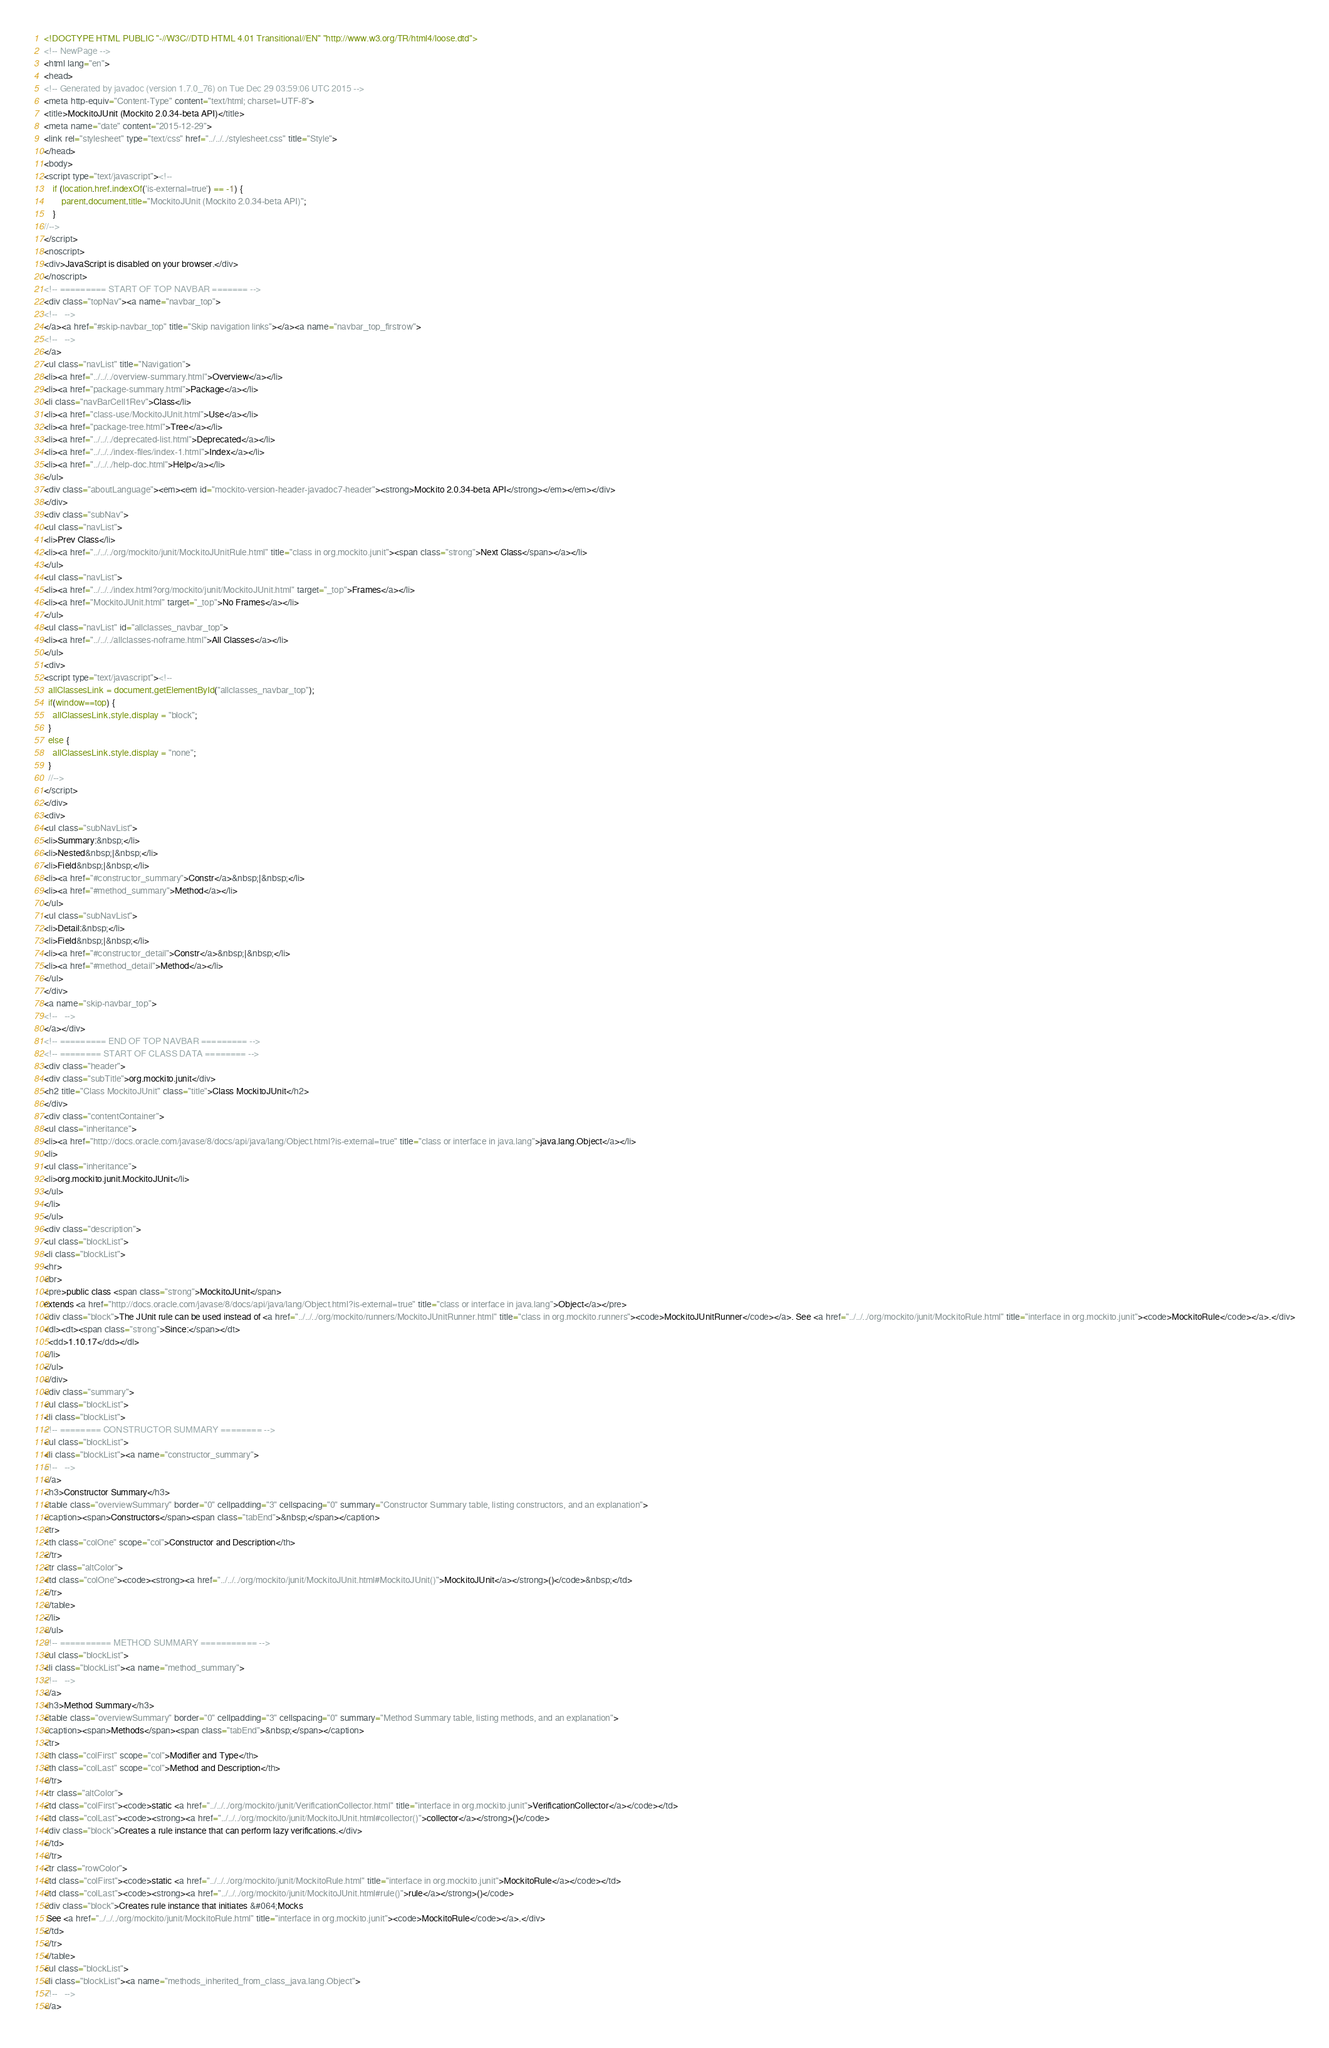<code> <loc_0><loc_0><loc_500><loc_500><_HTML_><!DOCTYPE HTML PUBLIC "-//W3C//DTD HTML 4.01 Transitional//EN" "http://www.w3.org/TR/html4/loose.dtd">
<!-- NewPage -->
<html lang="en">
<head>
<!-- Generated by javadoc (version 1.7.0_76) on Tue Dec 29 03:59:06 UTC 2015 -->
<meta http-equiv="Content-Type" content="text/html; charset=UTF-8">
<title>MockitoJUnit (Mockito 2.0.34-beta API)</title>
<meta name="date" content="2015-12-29">
<link rel="stylesheet" type="text/css" href="../../../stylesheet.css" title="Style">
</head>
<body>
<script type="text/javascript"><!--
    if (location.href.indexOf('is-external=true') == -1) {
        parent.document.title="MockitoJUnit (Mockito 2.0.34-beta API)";
    }
//-->
</script>
<noscript>
<div>JavaScript is disabled on your browser.</div>
</noscript>
<!-- ========= START OF TOP NAVBAR ======= -->
<div class="topNav"><a name="navbar_top">
<!--   -->
</a><a href="#skip-navbar_top" title="Skip navigation links"></a><a name="navbar_top_firstrow">
<!--   -->
</a>
<ul class="navList" title="Navigation">
<li><a href="../../../overview-summary.html">Overview</a></li>
<li><a href="package-summary.html">Package</a></li>
<li class="navBarCell1Rev">Class</li>
<li><a href="class-use/MockitoJUnit.html">Use</a></li>
<li><a href="package-tree.html">Tree</a></li>
<li><a href="../../../deprecated-list.html">Deprecated</a></li>
<li><a href="../../../index-files/index-1.html">Index</a></li>
<li><a href="../../../help-doc.html">Help</a></li>
</ul>
<div class="aboutLanguage"><em><em id="mockito-version-header-javadoc7-header"><strong>Mockito 2.0.34-beta API</strong></em></em></div>
</div>
<div class="subNav">
<ul class="navList">
<li>Prev Class</li>
<li><a href="../../../org/mockito/junit/MockitoJUnitRule.html" title="class in org.mockito.junit"><span class="strong">Next Class</span></a></li>
</ul>
<ul class="navList">
<li><a href="../../../index.html?org/mockito/junit/MockitoJUnit.html" target="_top">Frames</a></li>
<li><a href="MockitoJUnit.html" target="_top">No Frames</a></li>
</ul>
<ul class="navList" id="allclasses_navbar_top">
<li><a href="../../../allclasses-noframe.html">All Classes</a></li>
</ul>
<div>
<script type="text/javascript"><!--
  allClassesLink = document.getElementById("allclasses_navbar_top");
  if(window==top) {
    allClassesLink.style.display = "block";
  }
  else {
    allClassesLink.style.display = "none";
  }
  //-->
</script>
</div>
<div>
<ul class="subNavList">
<li>Summary:&nbsp;</li>
<li>Nested&nbsp;|&nbsp;</li>
<li>Field&nbsp;|&nbsp;</li>
<li><a href="#constructor_summary">Constr</a>&nbsp;|&nbsp;</li>
<li><a href="#method_summary">Method</a></li>
</ul>
<ul class="subNavList">
<li>Detail:&nbsp;</li>
<li>Field&nbsp;|&nbsp;</li>
<li><a href="#constructor_detail">Constr</a>&nbsp;|&nbsp;</li>
<li><a href="#method_detail">Method</a></li>
</ul>
</div>
<a name="skip-navbar_top">
<!--   -->
</a></div>
<!-- ========= END OF TOP NAVBAR ========= -->
<!-- ======== START OF CLASS DATA ======== -->
<div class="header">
<div class="subTitle">org.mockito.junit</div>
<h2 title="Class MockitoJUnit" class="title">Class MockitoJUnit</h2>
</div>
<div class="contentContainer">
<ul class="inheritance">
<li><a href="http://docs.oracle.com/javase/8/docs/api/java/lang/Object.html?is-external=true" title="class or interface in java.lang">java.lang.Object</a></li>
<li>
<ul class="inheritance">
<li>org.mockito.junit.MockitoJUnit</li>
</ul>
</li>
</ul>
<div class="description">
<ul class="blockList">
<li class="blockList">
<hr>
<br>
<pre>public class <span class="strong">MockitoJUnit</span>
extends <a href="http://docs.oracle.com/javase/8/docs/api/java/lang/Object.html?is-external=true" title="class or interface in java.lang">Object</a></pre>
<div class="block">The JUnit rule can be used instead of <a href="../../../org/mockito/runners/MockitoJUnitRunner.html" title="class in org.mockito.runners"><code>MockitoJUnitRunner</code></a>. See <a href="../../../org/mockito/junit/MockitoRule.html" title="interface in org.mockito.junit"><code>MockitoRule</code></a>.</div>
<dl><dt><span class="strong">Since:</span></dt>
  <dd>1.10.17</dd></dl>
</li>
</ul>
</div>
<div class="summary">
<ul class="blockList">
<li class="blockList">
<!-- ======== CONSTRUCTOR SUMMARY ======== -->
<ul class="blockList">
<li class="blockList"><a name="constructor_summary">
<!--   -->
</a>
<h3>Constructor Summary</h3>
<table class="overviewSummary" border="0" cellpadding="3" cellspacing="0" summary="Constructor Summary table, listing constructors, and an explanation">
<caption><span>Constructors</span><span class="tabEnd">&nbsp;</span></caption>
<tr>
<th class="colOne" scope="col">Constructor and Description</th>
</tr>
<tr class="altColor">
<td class="colOne"><code><strong><a href="../../../org/mockito/junit/MockitoJUnit.html#MockitoJUnit()">MockitoJUnit</a></strong>()</code>&nbsp;</td>
</tr>
</table>
</li>
</ul>
<!-- ========== METHOD SUMMARY =========== -->
<ul class="blockList">
<li class="blockList"><a name="method_summary">
<!--   -->
</a>
<h3>Method Summary</h3>
<table class="overviewSummary" border="0" cellpadding="3" cellspacing="0" summary="Method Summary table, listing methods, and an explanation">
<caption><span>Methods</span><span class="tabEnd">&nbsp;</span></caption>
<tr>
<th class="colFirst" scope="col">Modifier and Type</th>
<th class="colLast" scope="col">Method and Description</th>
</tr>
<tr class="altColor">
<td class="colFirst"><code>static <a href="../../../org/mockito/junit/VerificationCollector.html" title="interface in org.mockito.junit">VerificationCollector</a></code></td>
<td class="colLast"><code><strong><a href="../../../org/mockito/junit/MockitoJUnit.html#collector()">collector</a></strong>()</code>
<div class="block">Creates a rule instance that can perform lazy verifications.</div>
</td>
</tr>
<tr class="rowColor">
<td class="colFirst"><code>static <a href="../../../org/mockito/junit/MockitoRule.html" title="interface in org.mockito.junit">MockitoRule</a></code></td>
<td class="colLast"><code><strong><a href="../../../org/mockito/junit/MockitoJUnit.html#rule()">rule</a></strong>()</code>
<div class="block">Creates rule instance that initiates &#064;Mocks
 See <a href="../../../org/mockito/junit/MockitoRule.html" title="interface in org.mockito.junit"><code>MockitoRule</code></a>.</div>
</td>
</tr>
</table>
<ul class="blockList">
<li class="blockList"><a name="methods_inherited_from_class_java.lang.Object">
<!--   -->
</a></code> 